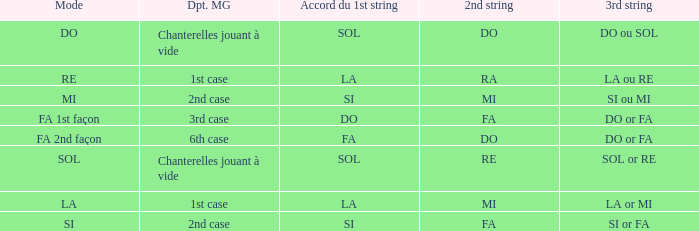What is the mode of the Depart de la main gauche of 1st case and a la or mi 3rd string? LA. 